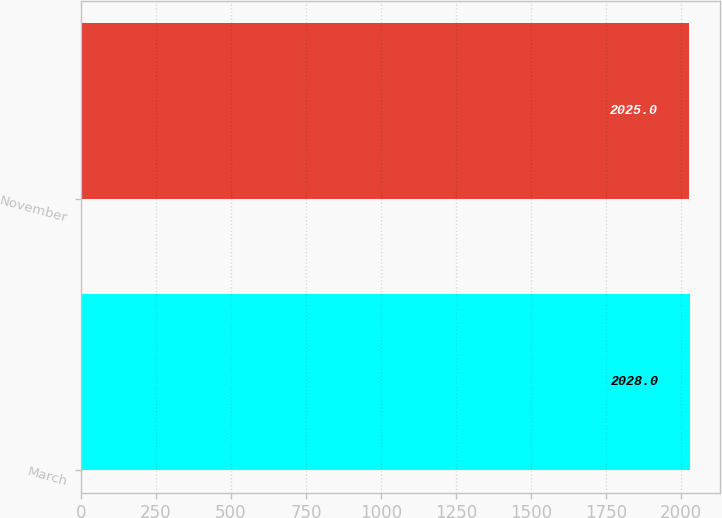Convert chart. <chart><loc_0><loc_0><loc_500><loc_500><bar_chart><fcel>March<fcel>November<nl><fcel>2028<fcel>2025<nl></chart> 